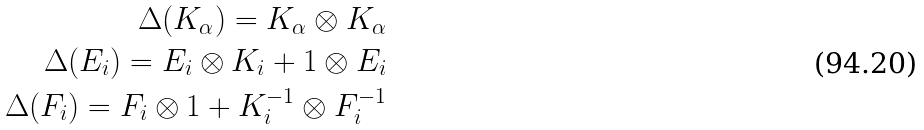<formula> <loc_0><loc_0><loc_500><loc_500>\Delta ( K _ { \alpha } ) = K _ { \alpha } \otimes K _ { \alpha } \\ \Delta ( E _ { i } ) = E _ { i } \otimes K _ { i } + 1 \otimes E _ { i } \\ \Delta ( F _ { i } ) = F _ { i } \otimes 1 + K _ { i } ^ { - 1 } \otimes F _ { i } ^ { - 1 }</formula> 